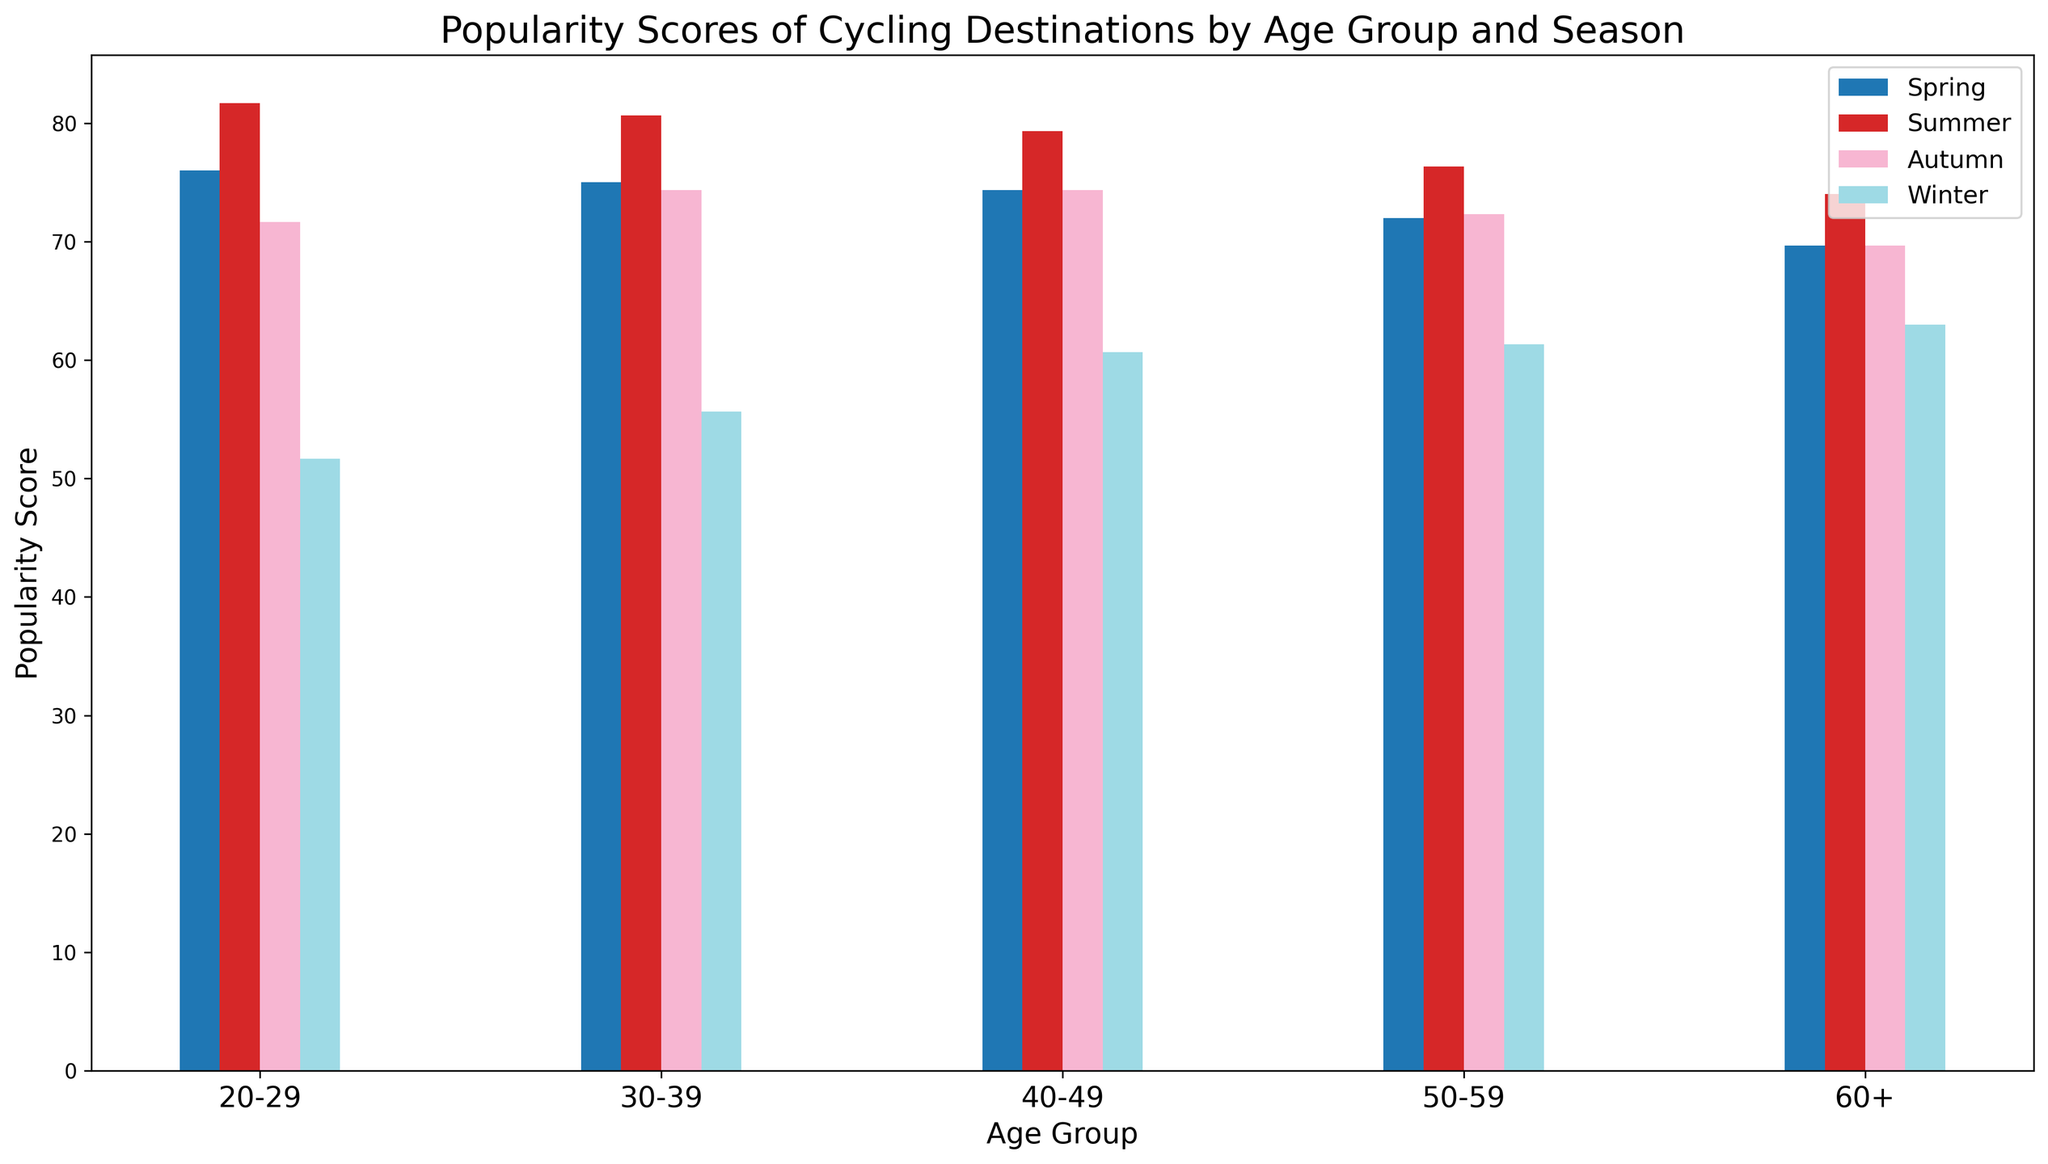Which age group has the highest average popularity score for cycling destinations? To find the average popularity score for each age group across all seasons, we sum the scores for each age group in all seasons and then divide by the number of seasons (4). For example, 20-29 age group has scores (85+78+65)+(90+85+70)+(75+80+60)+(50+65+40)=843. Dividing by 4 gives an average of 210.75. Repeat for other age groups and compare.
Answer: 20-29 Which season has the lowest average popularity score across all age groups? We sum the scores for all age groups in each season and find the average. For Spring, scores are (85+78+65)+(82+75+68)+(80+73+70)+(78+70+68)+(75+68+66)=1033. Divide by 5, Spring Average = 206.6. Repeat for other seasons and compare.
Answer: Winter What is the difference in popularity scores between the 20-29 age group and the 60+ age group in the Summer season? Look at the Summer season and compare the scores for the 20-29 age group (90+85+70) and the 60+ age group (80+72+70). The difference is (245 - 222).
Answer: 23 Which cycling destination is most popular among the 50-59 age group in Autumn? Check the chart for the 50-59 age group in Autumn season and compare Amsterdam, Barcelona, and Portland. The scores are 75, 78, and 64.
Answer: Barcelona During which season is the popularity score for Portland highest in the 30-39 age group? Look at the chart for Portland in the 30-39 age group and note the scores for each season: Spring (68), Summer (72), Autumn (62), Winter (45). Summer has the highest score.
Answer: Summer Which age group prefers Amsterdam the most in the Winter season? Compare the scores for Amsterdam in Winter across all age groups. The scores are: 20-29 (50), 30-39 (55), 40-49 (60), 50-59 (62), 60+ (65). The 60+ age group has the highest score.
Answer: 60+ What is the average popularity score for Barcelona across all age groups in Autumn? Add up the Autumn scores for Barcelona across all age groups and divide by the number of age groups (5). The scores are: 20-29 (80), 30-39 (83), 40-49 (81), 50-59 (78), 60+ (76). Sum is 398, average = 398/5.
Answer: 79.6 By how much does the popularity score of Barcelona in the Winter season differ between the youngest (20-29) and the oldest (60+) age groups? Compare the Winter scores for Barcelona in the 20-29 age group (65) and the 60+ age group (69). The difference is (69 - 65).
Answer: 4 What is the most common popularity score range (e.g., 50-60, 60-70, etc.) across all destinations and age groups in the Spring season? Identify the popularity scores for Spring for all destinations and age groups. Count the occurrences of scores within each range: 20-29 (85+78+65), 30-39 (82+75+68), 40-49 (80+73+70), 50-59 (78+70+68), 60+ (75+68+66). The range 70-80 appears most frequently.
Answer: 70-80 